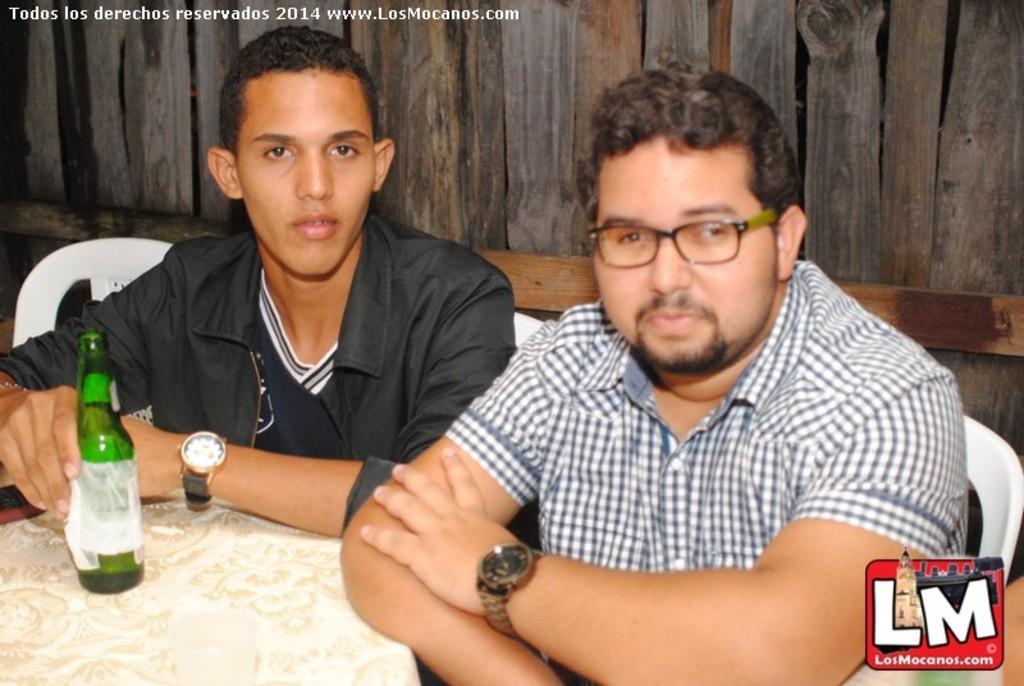Please provide a concise description of this image. These two men are sitting on the chairs. This man is wearing a spectacle, shirt, and watch. This man is wearing a jacket, T-Shirt and a watch. This bottle is on the table. In the background, there is wooden wall. 